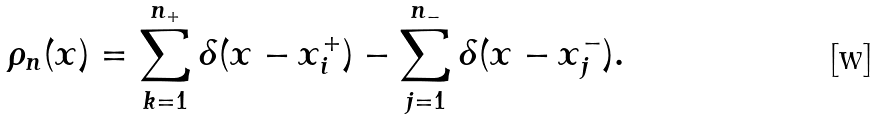Convert formula to latex. <formula><loc_0><loc_0><loc_500><loc_500>\rho _ { n } ( x ) = \sum _ { k = 1 } ^ { n _ { + } } \delta ( x - x _ { i } ^ { + } ) - \sum _ { j = 1 } ^ { n _ { - } } \delta ( x - x _ { j } ^ { - } ) .</formula> 